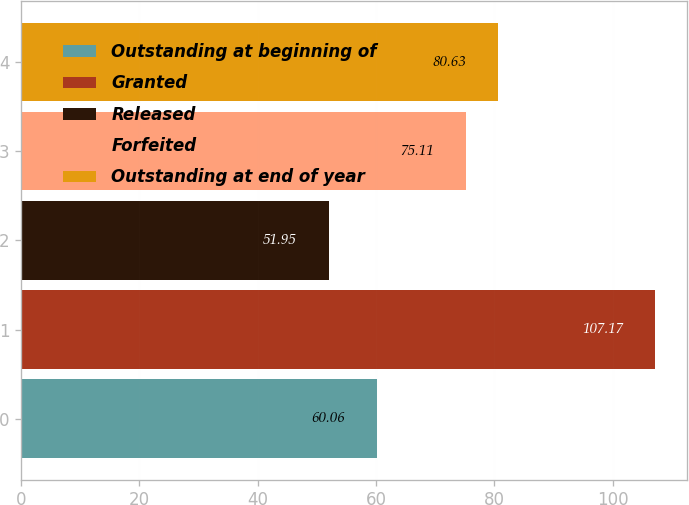<chart> <loc_0><loc_0><loc_500><loc_500><bar_chart><fcel>Outstanding at beginning of<fcel>Granted<fcel>Released<fcel>Forfeited<fcel>Outstanding at end of year<nl><fcel>60.06<fcel>107.17<fcel>51.95<fcel>75.11<fcel>80.63<nl></chart> 